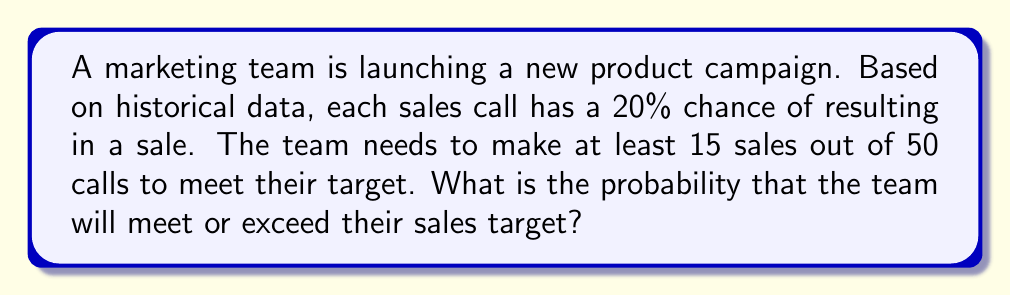Could you help me with this problem? Let's approach this step-by-step using the binomial distribution:

1) This scenario fits a binomial distribution because:
   - There's a fixed number of trials (50 calls)
   - Each trial has two possible outcomes (sale or no sale)
   - The probability of success (20% or 0.2) is constant for each trial
   - The trials are independent

2) We want to find P(X ≥ 15), where X is the number of successful sales.

3) The binomial probability formula is:

   $$P(X = k) = \binom{n}{k} p^k (1-p)^{n-k}$$

   Where:
   n = number of trials (50)
   k = number of successes
   p = probability of success on each trial (0.2)

4) However, we need the cumulative probability for X ≥ 15. This means:

   $$P(X \geq 15) = P(X = 15) + P(X = 16) + ... + P(X = 50)$$

5) This can be calculated as:

   $$P(X \geq 15) = 1 - [P(X = 0) + P(X = 1) + ... + P(X = 14)]$$

6) Using a calculator or software with binomial distribution functions, we can compute this as:

   $$P(X \geq 15) = 1 - P(X \leq 14)$$
   $$= 1 - \text{BINOM.DIST}(14, 50, 0.2, \text{TRUE})$$
   $$\approx 1 - 0.8131$$
   $$\approx 0.1869$$

7) Converting to a percentage: 0.1869 * 100 ≈ 18.69%

Therefore, the probability that the team will meet or exceed their sales target is approximately 18.69%.
Answer: 18.69% 